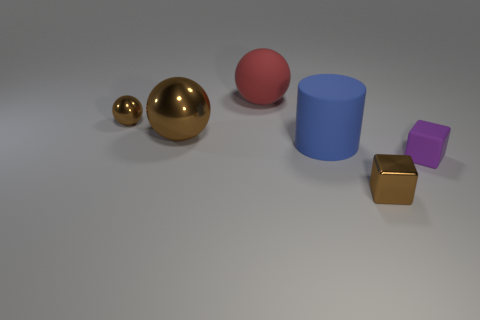What is the color of the tiny object on the left side of the thing in front of the purple matte block?
Provide a succinct answer. Brown. What number of balls are either blue metal objects or big blue rubber things?
Make the answer very short. 0. There is a tiny brown thing behind the small brown metal thing that is on the right side of the big metallic object; how many large blue cylinders are right of it?
Ensure brevity in your answer.  1. There is a metal block that is the same color as the small sphere; what size is it?
Ensure brevity in your answer.  Small. Are there any objects that have the same material as the tiny sphere?
Offer a very short reply. Yes. Is the purple cube made of the same material as the big blue thing?
Give a very brief answer. Yes. There is a tiny thing in front of the rubber block; what number of matte objects are on the left side of it?
Provide a short and direct response. 2. What number of brown things are tiny metal balls or tiny things?
Give a very brief answer. 2. What shape is the tiny brown object behind the small metallic thing that is right of the small brown object that is left of the red ball?
Make the answer very short. Sphere. The matte object that is the same size as the metal block is what color?
Provide a short and direct response. Purple. 